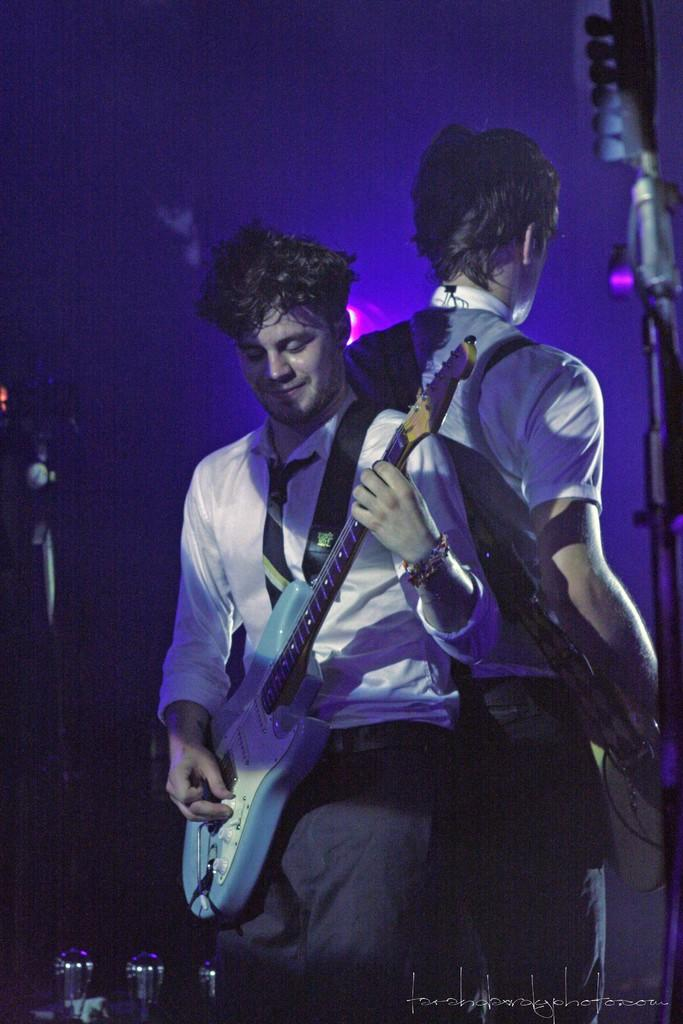How many people are in the image? There are two persons in the image. What are the persons doing in the image? The persons are playing musical instruments. What objects can be seen in the image besides the people and their instruments? There are poles and lights in the image. What information is provided at the bottom of the image? There is text at the bottom of the image. Can you see a window in the image? There is no window present in the image. What type of water is visible in the image? There is no water present in the image. 